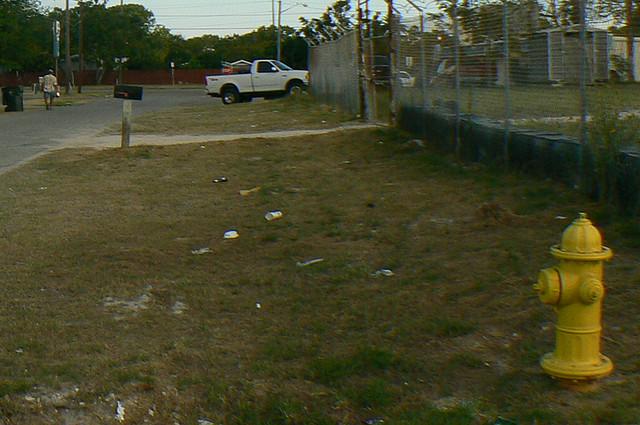What metal structure is behind the fire hydrant?
Give a very brief answer. Fence. What is the color of the hydrant?
Concise answer only. Yellow. Where is the fire hydrant?
Quick response, please. Grass. What color is the truck?
Concise answer only. White. What is behind the fence?
Concise answer only. Shed. What color is the hydrant?
Give a very brief answer. Yellow. Is this a corner property?
Quick response, please. No. What color is the fire hydrant?
Write a very short answer. Yellow. Is the grass green or brown?
Answer briefly. Green. Is am not sure what this is but Is think it is used for eulogies and can light a room?
Keep it brief. No. How many people can be seen?
Keep it brief. 1. 